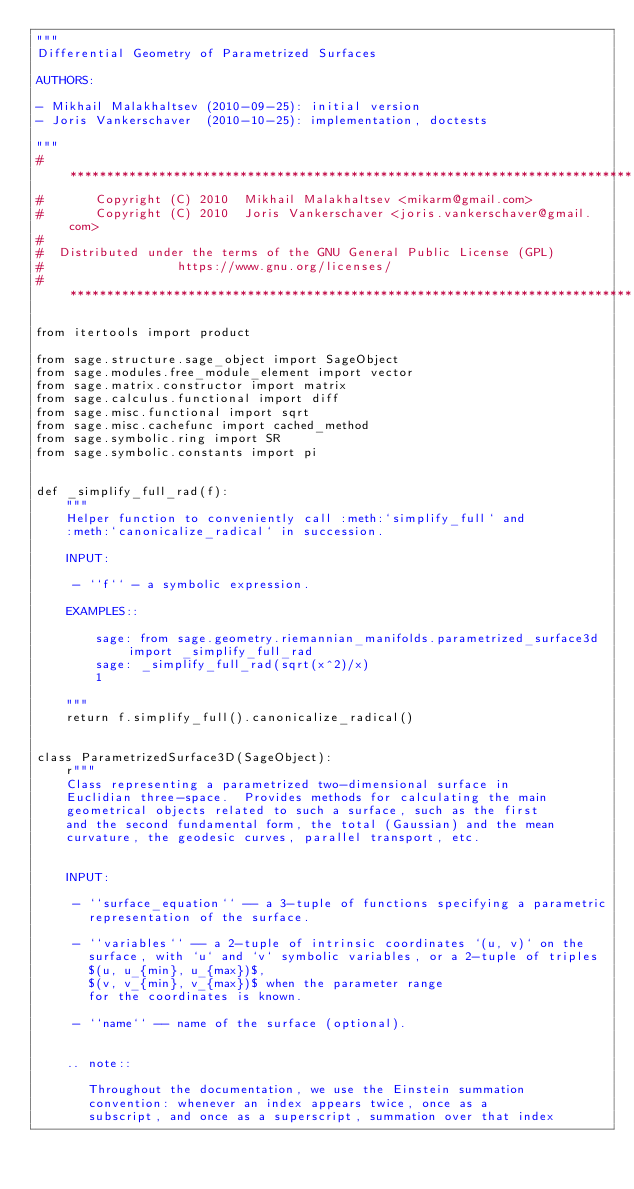Convert code to text. <code><loc_0><loc_0><loc_500><loc_500><_Python_>"""
Differential Geometry of Parametrized Surfaces

AUTHORS:

- Mikhail Malakhaltsev (2010-09-25): initial version
- Joris Vankerschaver  (2010-10-25): implementation, doctests

"""
# ****************************************************************************
#       Copyright (C) 2010  Mikhail Malakhaltsev <mikarm@gmail.com>
#       Copyright (C) 2010  Joris Vankerschaver <joris.vankerschaver@gmail.com>
#
#  Distributed under the terms of the GNU General Public License (GPL)
#                  https://www.gnu.org/licenses/
# ****************************************************************************

from itertools import product

from sage.structure.sage_object import SageObject
from sage.modules.free_module_element import vector
from sage.matrix.constructor import matrix
from sage.calculus.functional import diff
from sage.misc.functional import sqrt
from sage.misc.cachefunc import cached_method
from sage.symbolic.ring import SR
from sage.symbolic.constants import pi


def _simplify_full_rad(f):
    """
    Helper function to conveniently call :meth:`simplify_full` and
    :meth:`canonicalize_radical` in succession.

    INPUT:

     - ``f`` - a symbolic expression.

    EXAMPLES::

        sage: from sage.geometry.riemannian_manifolds.parametrized_surface3d import _simplify_full_rad
        sage: _simplify_full_rad(sqrt(x^2)/x)
        1

    """
    return f.simplify_full().canonicalize_radical()


class ParametrizedSurface3D(SageObject):
    r"""
    Class representing a parametrized two-dimensional surface in
    Euclidian three-space.  Provides methods for calculating the main
    geometrical objects related to such a surface, such as the first
    and the second fundamental form, the total (Gaussian) and the mean
    curvature, the geodesic curves, parallel transport, etc.


    INPUT:

     - ``surface_equation`` -- a 3-tuple of functions specifying a parametric
       representation of the surface.

     - ``variables`` -- a 2-tuple of intrinsic coordinates `(u, v)` on the
       surface, with `u` and `v` symbolic variables, or a 2-tuple of triples
       $(u, u_{min}, u_{max})$,
       $(v, v_{min}, v_{max})$ when the parameter range
       for the coordinates is known.

     - ``name`` -- name of the surface (optional).


    .. note::

       Throughout the documentation, we use the Einstein summation
       convention: whenever an index appears twice, once as a
       subscript, and once as a superscript, summation over that index</code> 